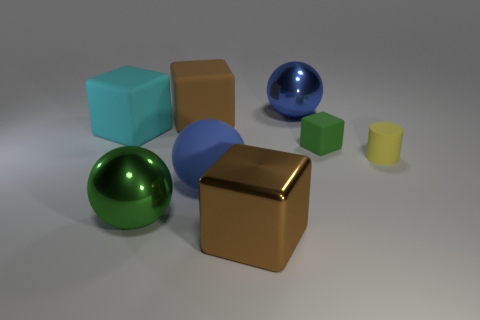Subtract all cyan cubes. How many cubes are left? 3 Add 1 big green metal cylinders. How many objects exist? 9 Subtract all red cubes. Subtract all yellow cylinders. How many cubes are left? 4 Subtract all cylinders. How many objects are left? 7 Add 4 green matte cubes. How many green matte cubes are left? 5 Add 4 large brown matte blocks. How many large brown matte blocks exist? 5 Subtract 0 gray cylinders. How many objects are left? 8 Subtract all big matte things. Subtract all small cylinders. How many objects are left? 4 